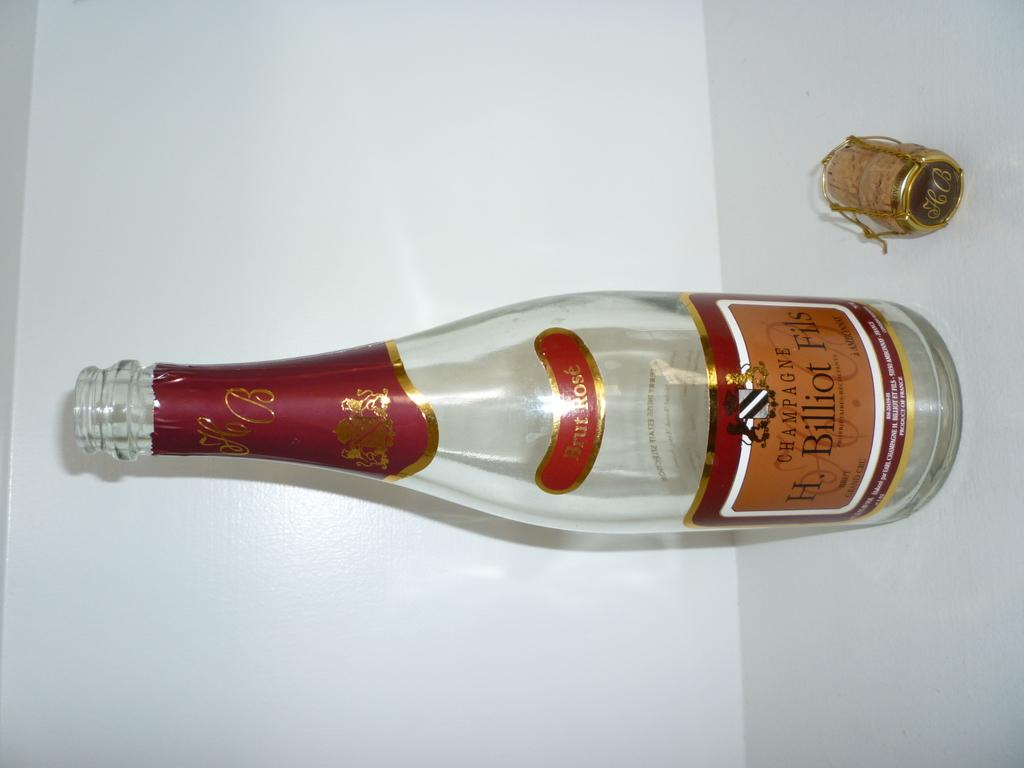<image>
Create a compact narrative representing the image presented. An empty bottle of H. Biilliot Fils champagne sits on a counter 